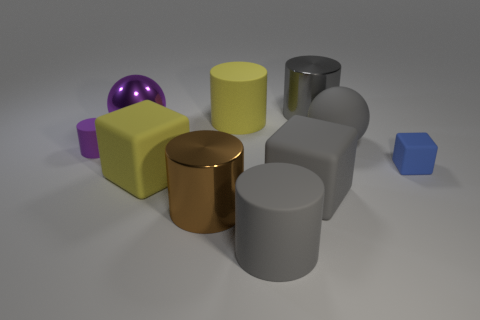What number of objects are objects on the left side of the big purple ball or tiny cyan matte things?
Give a very brief answer. 1. The gray block that is the same material as the yellow block is what size?
Provide a short and direct response. Large. Is the number of brown metal things on the right side of the blue thing greater than the number of small blue objects?
Offer a terse response. No. There is a large gray metal object; is it the same shape as the metal thing in front of the rubber sphere?
Your response must be concise. Yes. What number of large objects are either gray rubber objects or purple rubber things?
Offer a terse response. 3. What size is the thing that is the same color as the tiny cylinder?
Ensure brevity in your answer.  Large. There is a big shiny thing in front of the large cube in front of the large yellow matte cube; what is its color?
Your answer should be very brief. Brown. Is the material of the gray cube the same as the big block that is behind the large gray block?
Keep it short and to the point. Yes. There is a small thing that is behind the tiny cube; what is its material?
Your answer should be very brief. Rubber. Is the number of blue matte things behind the small matte block the same as the number of yellow matte cylinders?
Offer a very short reply. No. 